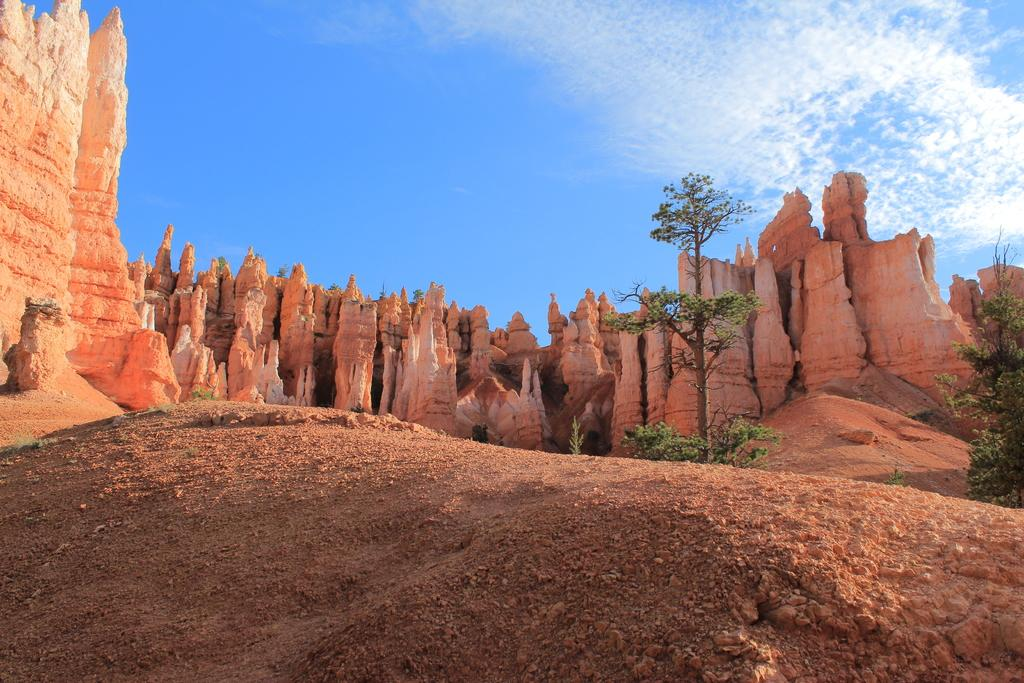What type of natural formation can be seen in the image? There are mountains in the image. What is visible at the top of the image? The sky is visible at the top of the image. What can be seen in the sky? Clouds are present in the sky. What type of vegetation is on the right side of the image? There are trees on the right side of the image. What type of society can be seen living among the mountains in the image? There is no society visible in the image; it only features mountains, the sky, clouds, and trees. What type of dinosaurs can be seen roaming the mountains in the image? There are no dinosaurs present in the image; it only features mountains, the sky, clouds, and trees. 